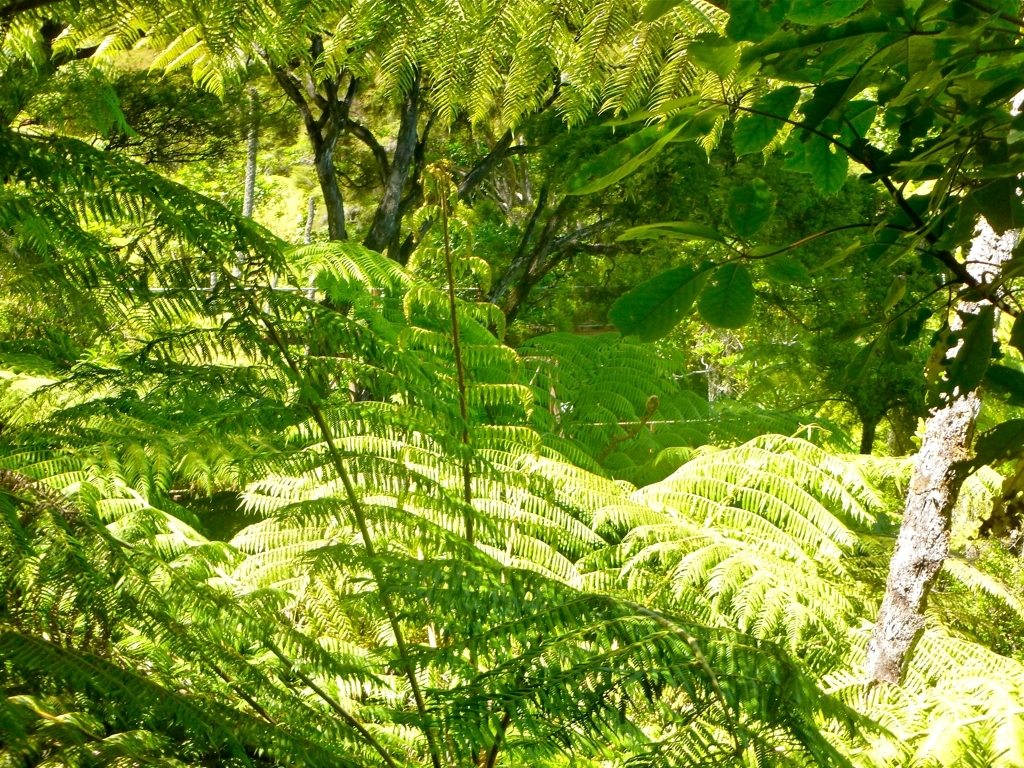How would you rate the quality of this picture?
A. The quality of this picture is poor.
B. The quality of this picture is relatively high.
C. The quality of this picture is average.
Answer with the option's letter from the given choices directly.
 B. 